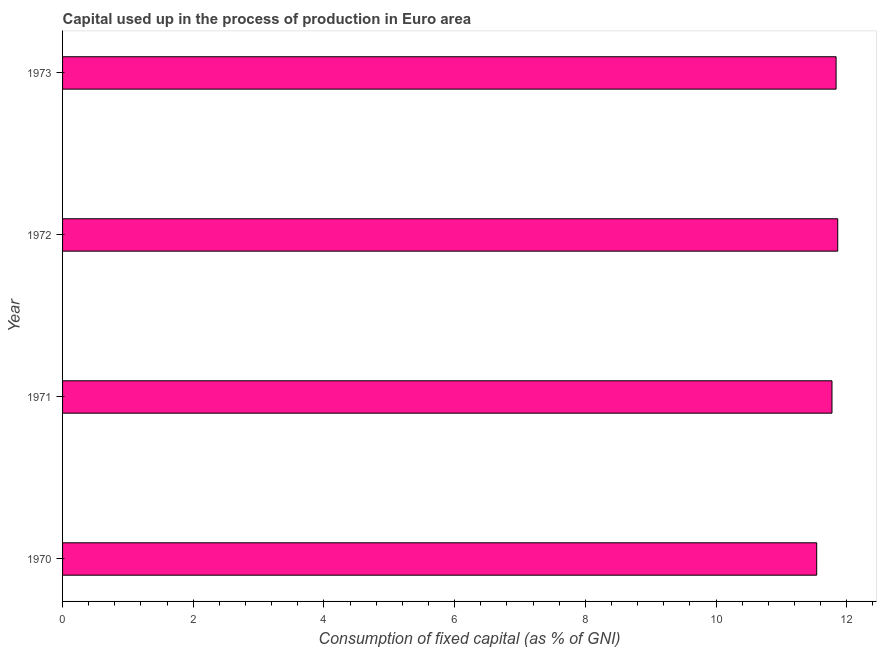Does the graph contain grids?
Offer a very short reply. No. What is the title of the graph?
Provide a succinct answer. Capital used up in the process of production in Euro area. What is the label or title of the X-axis?
Offer a terse response. Consumption of fixed capital (as % of GNI). What is the label or title of the Y-axis?
Keep it short and to the point. Year. What is the consumption of fixed capital in 1972?
Provide a succinct answer. 11.86. Across all years, what is the maximum consumption of fixed capital?
Provide a short and direct response. 11.86. Across all years, what is the minimum consumption of fixed capital?
Keep it short and to the point. 11.54. In which year was the consumption of fixed capital maximum?
Your answer should be very brief. 1972. In which year was the consumption of fixed capital minimum?
Provide a succinct answer. 1970. What is the sum of the consumption of fixed capital?
Give a very brief answer. 47.01. What is the difference between the consumption of fixed capital in 1970 and 1971?
Offer a terse response. -0.23. What is the average consumption of fixed capital per year?
Offer a very short reply. 11.75. What is the median consumption of fixed capital?
Keep it short and to the point. 11.81. Do a majority of the years between 1973 and 1970 (inclusive) have consumption of fixed capital greater than 1.2 %?
Give a very brief answer. Yes. What is the ratio of the consumption of fixed capital in 1970 to that in 1972?
Your answer should be very brief. 0.97. What is the difference between the highest and the second highest consumption of fixed capital?
Your answer should be very brief. 0.03. What is the difference between the highest and the lowest consumption of fixed capital?
Your answer should be very brief. 0.32. How many bars are there?
Give a very brief answer. 4. Are all the bars in the graph horizontal?
Offer a very short reply. Yes. What is the Consumption of fixed capital (as % of GNI) of 1970?
Give a very brief answer. 11.54. What is the Consumption of fixed capital (as % of GNI) in 1971?
Make the answer very short. 11.77. What is the Consumption of fixed capital (as % of GNI) of 1972?
Ensure brevity in your answer.  11.86. What is the Consumption of fixed capital (as % of GNI) in 1973?
Ensure brevity in your answer.  11.84. What is the difference between the Consumption of fixed capital (as % of GNI) in 1970 and 1971?
Your answer should be compact. -0.23. What is the difference between the Consumption of fixed capital (as % of GNI) in 1970 and 1972?
Provide a succinct answer. -0.32. What is the difference between the Consumption of fixed capital (as % of GNI) in 1970 and 1973?
Your response must be concise. -0.3. What is the difference between the Consumption of fixed capital (as % of GNI) in 1971 and 1972?
Give a very brief answer. -0.09. What is the difference between the Consumption of fixed capital (as % of GNI) in 1971 and 1973?
Make the answer very short. -0.06. What is the difference between the Consumption of fixed capital (as % of GNI) in 1972 and 1973?
Ensure brevity in your answer.  0.03. What is the ratio of the Consumption of fixed capital (as % of GNI) in 1970 to that in 1971?
Give a very brief answer. 0.98. What is the ratio of the Consumption of fixed capital (as % of GNI) in 1970 to that in 1972?
Your answer should be very brief. 0.97. What is the ratio of the Consumption of fixed capital (as % of GNI) in 1971 to that in 1973?
Your response must be concise. 0.99. What is the ratio of the Consumption of fixed capital (as % of GNI) in 1972 to that in 1973?
Offer a very short reply. 1. 